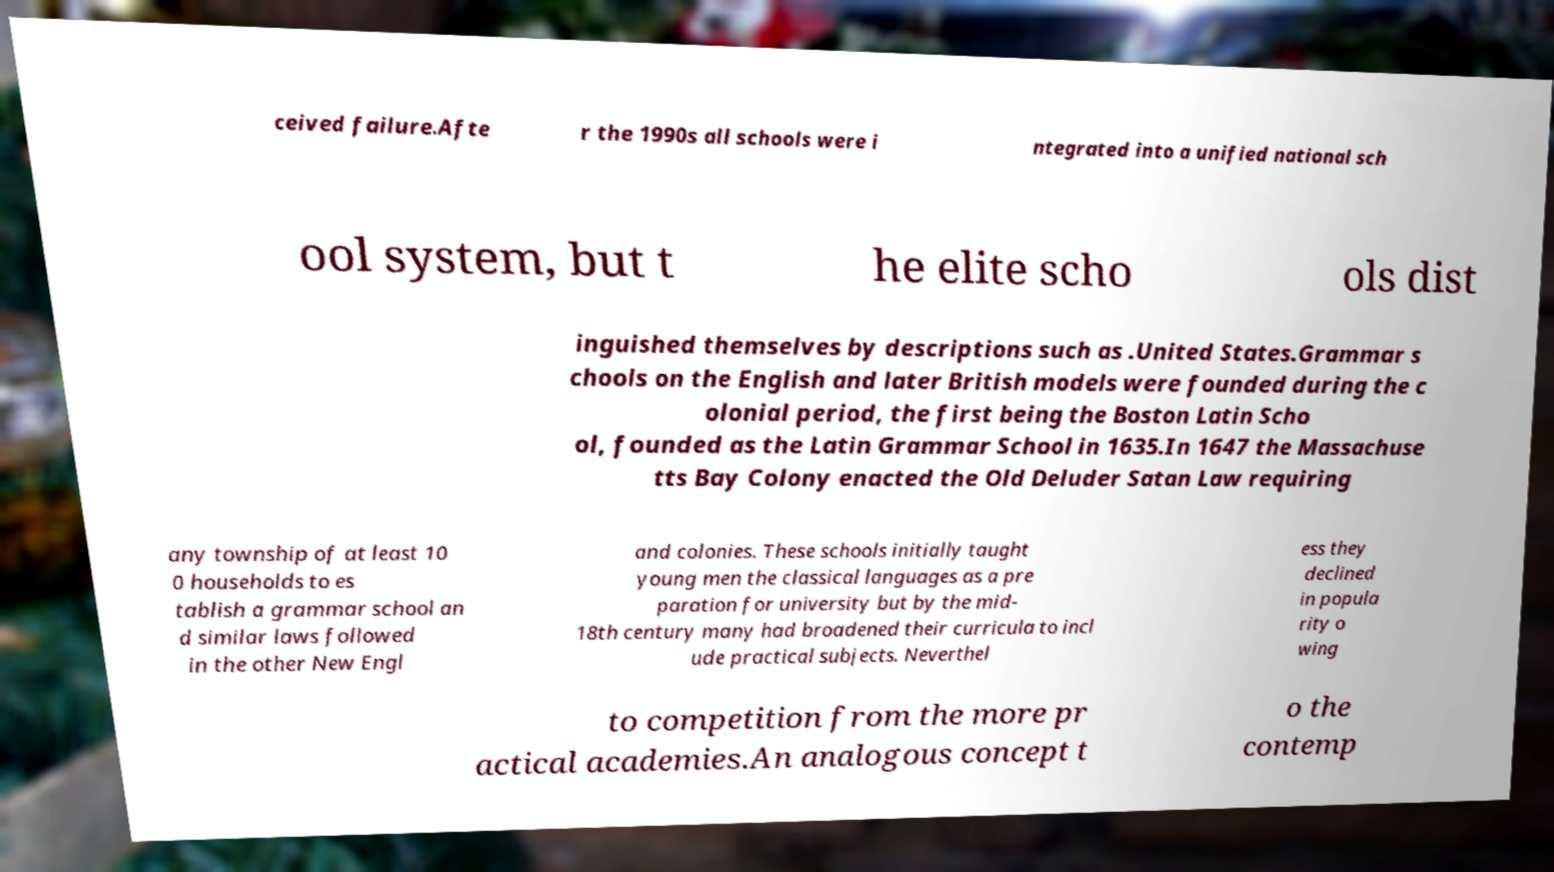Can you accurately transcribe the text from the provided image for me? ceived failure.Afte r the 1990s all schools were i ntegrated into a unified national sch ool system, but t he elite scho ols dist inguished themselves by descriptions such as .United States.Grammar s chools on the English and later British models were founded during the c olonial period, the first being the Boston Latin Scho ol, founded as the Latin Grammar School in 1635.In 1647 the Massachuse tts Bay Colony enacted the Old Deluder Satan Law requiring any township of at least 10 0 households to es tablish a grammar school an d similar laws followed in the other New Engl and colonies. These schools initially taught young men the classical languages as a pre paration for university but by the mid- 18th century many had broadened their curricula to incl ude practical subjects. Neverthel ess they declined in popula rity o wing to competition from the more pr actical academies.An analogous concept t o the contemp 